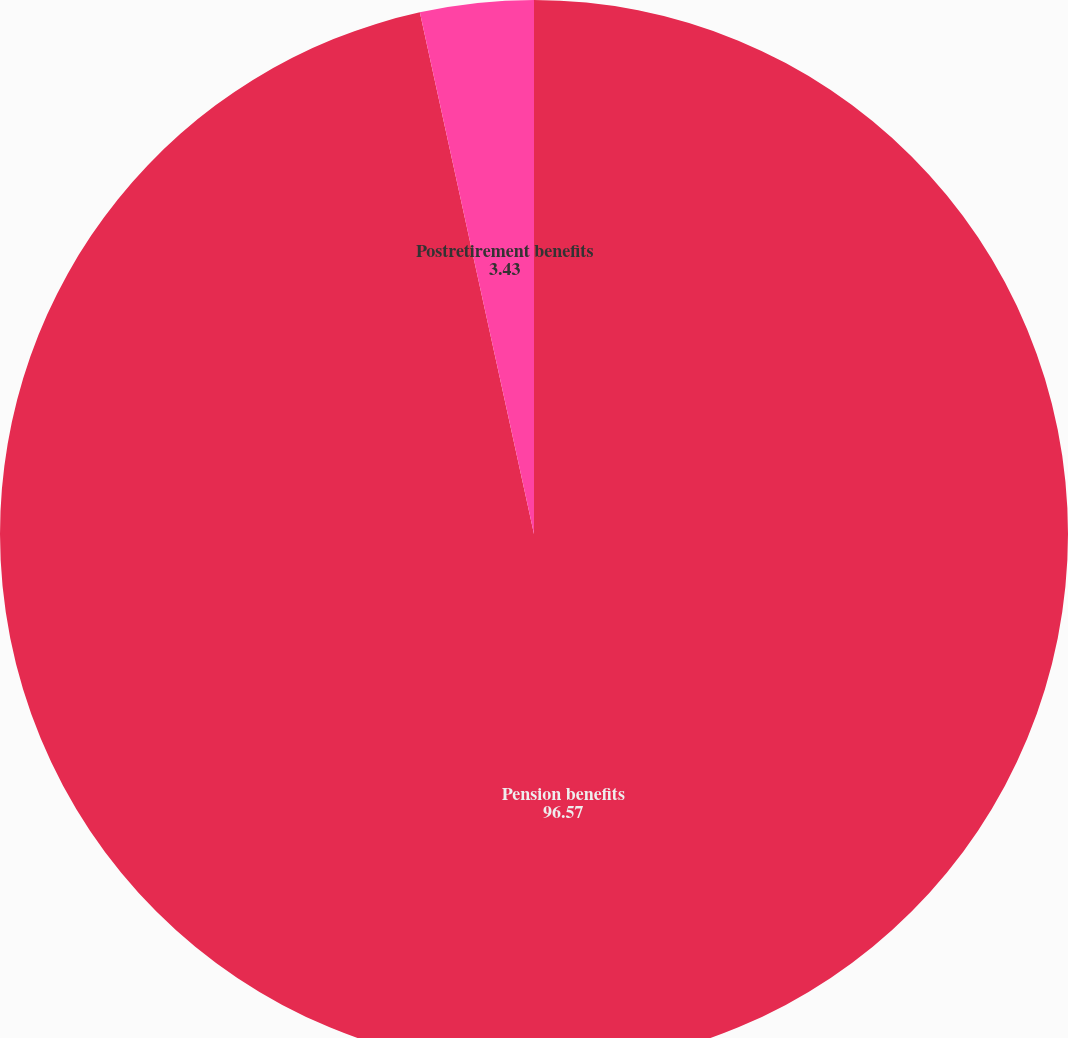Convert chart. <chart><loc_0><loc_0><loc_500><loc_500><pie_chart><fcel>Pension benefits<fcel>Postretirement benefits<nl><fcel>96.57%<fcel>3.43%<nl></chart> 